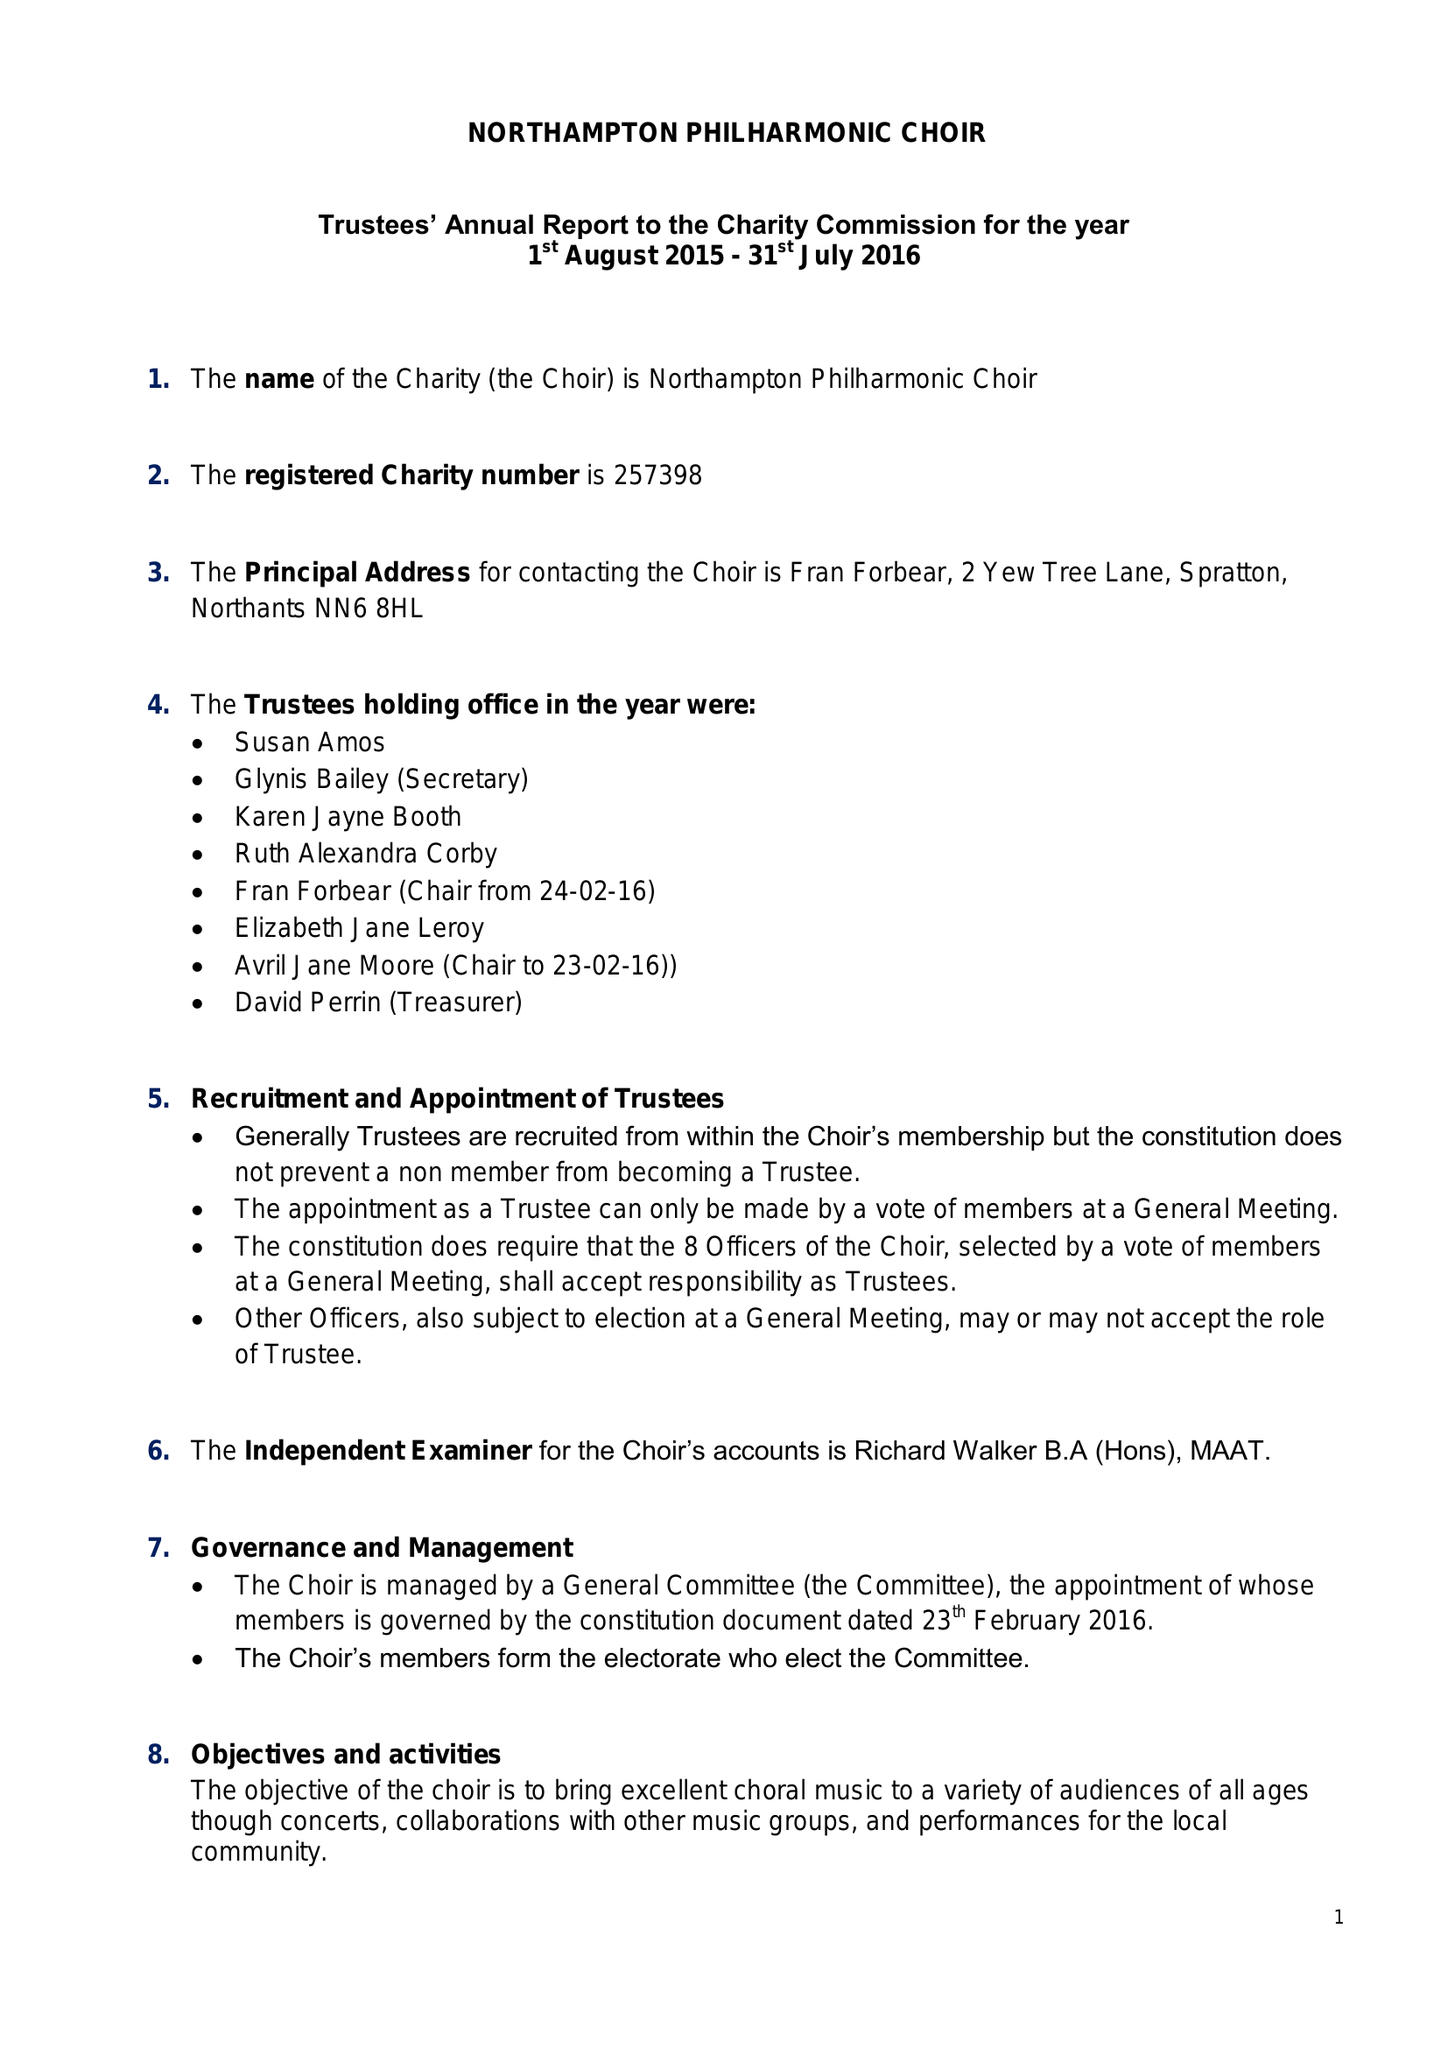What is the value for the income_annually_in_british_pounds?
Answer the question using a single word or phrase. 26688.00 